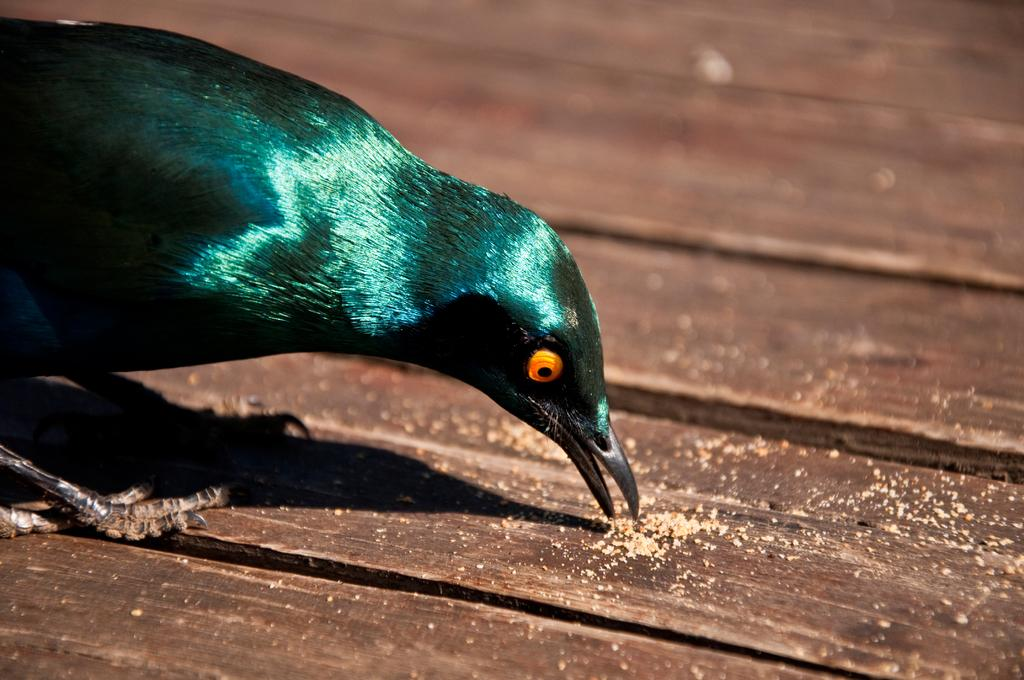What type of animal can be seen in the image? There is a bird in the image. Where is the bird located in the image? The bird is on the left side of the image. What surface is the bird resting on? The bird is on a wooden surface. Is the bird shaking the tree in the image? There is no tree present in the image, and the bird is not shaking anything. 